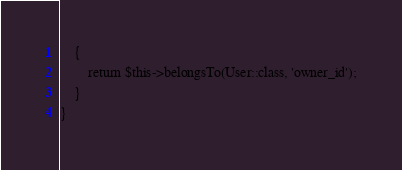<code> <loc_0><loc_0><loc_500><loc_500><_PHP_>    {
        return $this->belongsTo(User::class, 'owner_id');
    }
}
</code> 